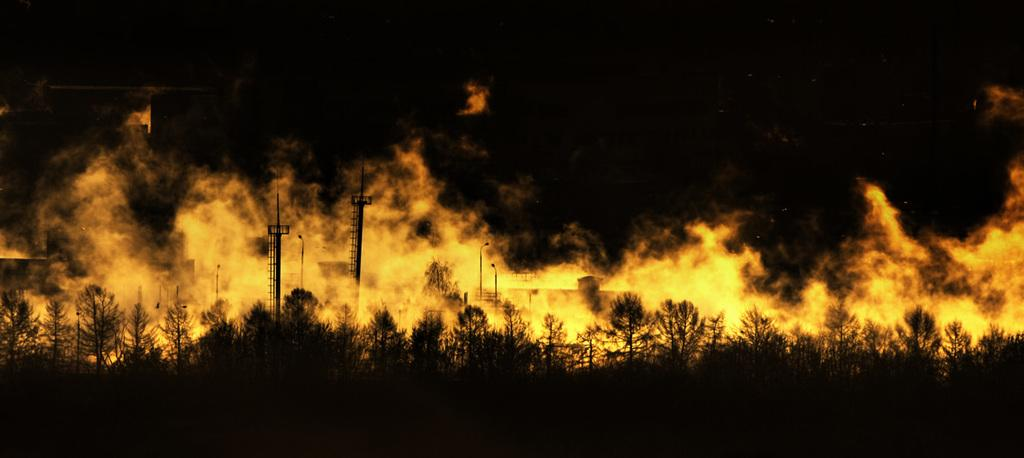What type of natural elements can be seen in the image? There are trees in the image. What man-made structures are present in the image? There are current poles and buildings in the image. Is there any indication of a source of energy in the image? Yes, there are current poles in the image, which are used to transmit electricity. What is the lighting condition in the image? The image is a little dark. Can you describe the presence of fire in the image? Yes, there is fire in the image. What type of creature is sitting on the grandmother's lap in the image? There is no creature or grandmother present in the image. Is there a hill visible in the image? There is no hill visible in the image. 